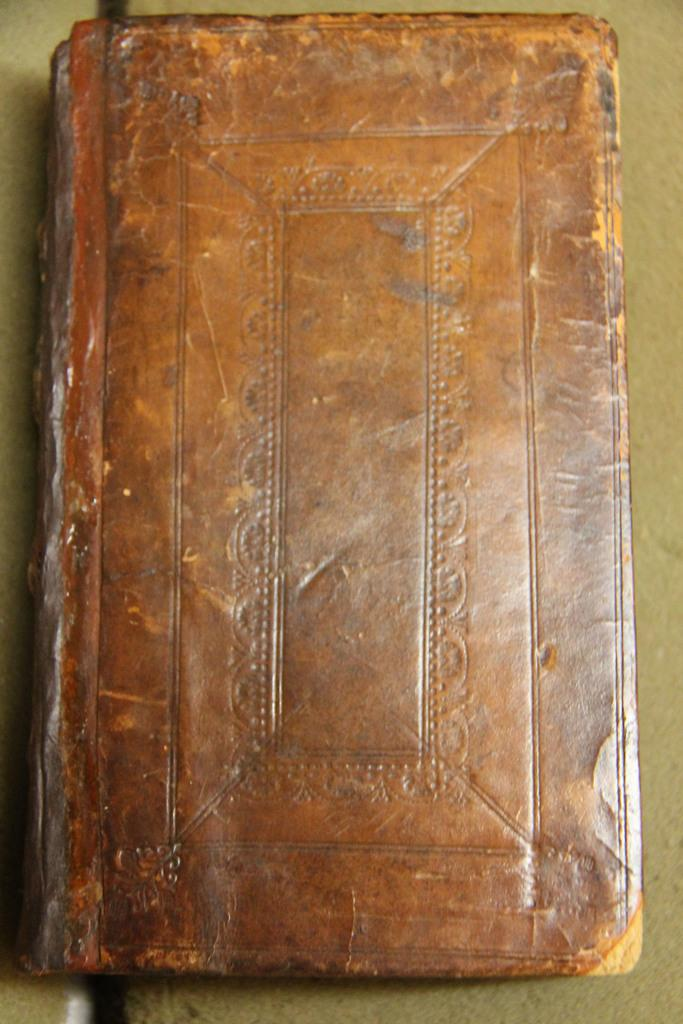What is the main object in the image? There is a book in the image. What is the book placed on? The book is on a green surface. Where is the mom in the image? There is no mom present in the image; it only features a book on a green surface. 